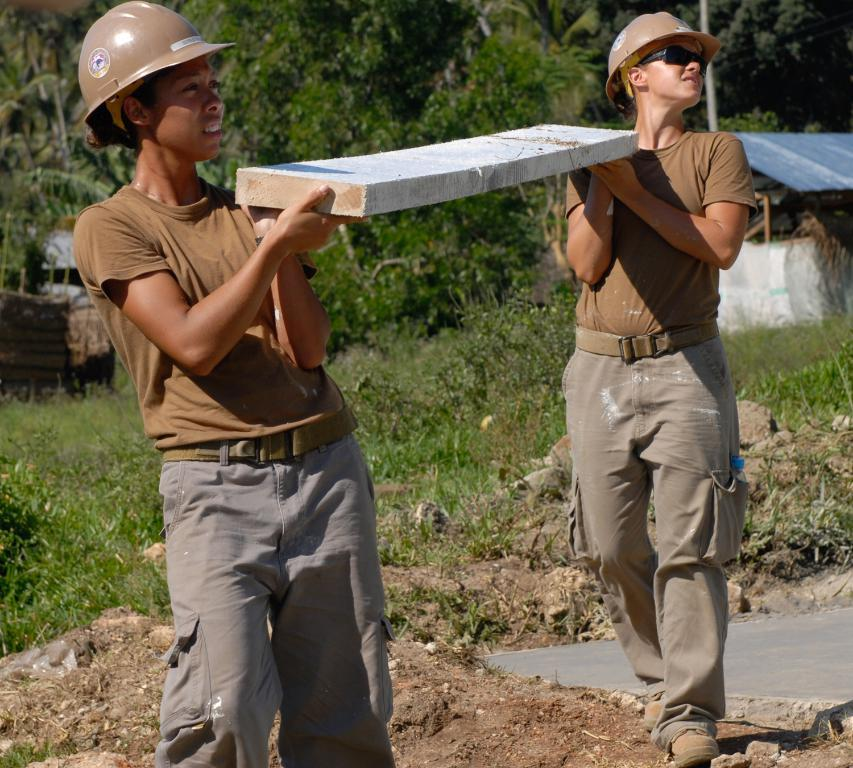How many people are in the image? There are two people in the image. What are the two people doing in the image? The two people are standing. What object are the two people holding in the image? The two people are holding a stone. What type of natural environment is visible in the image? There are trees in the image. What is the condition of the ground in the image? The ground appears to be muddy. What type of structure is visible in the image? There is no structure present in the image; it features two people standing and holding a stone in a natural environment with trees. How many seats are visible in the image? There are no seats visible in the image. 